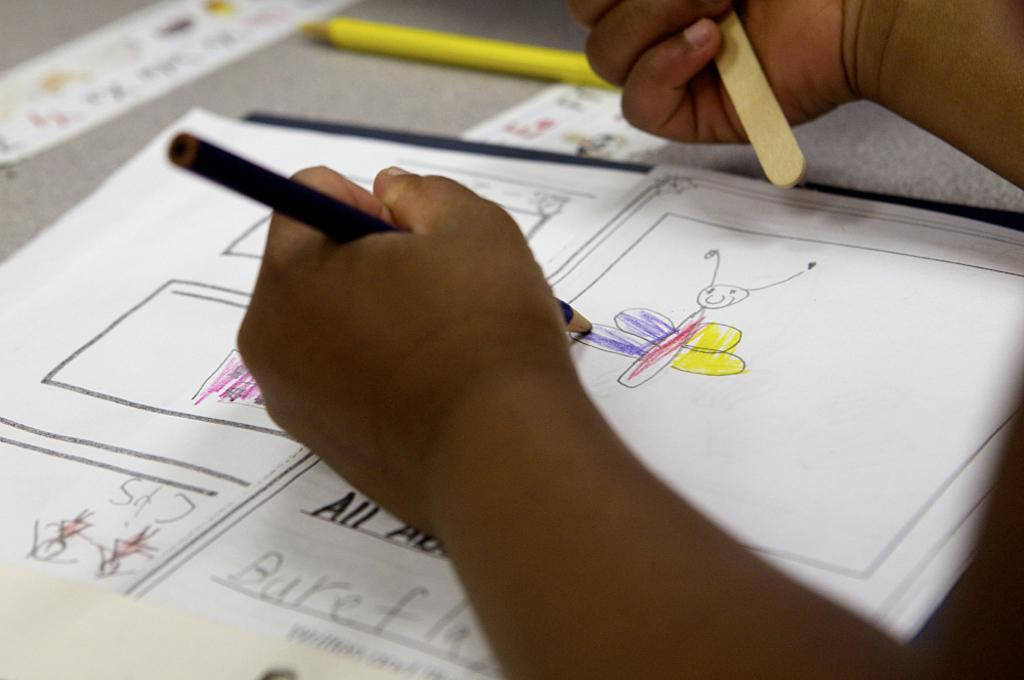<image>
Create a compact narrative representing the image presented. A child is drawing a butterfly on a paper with the word All on it. 